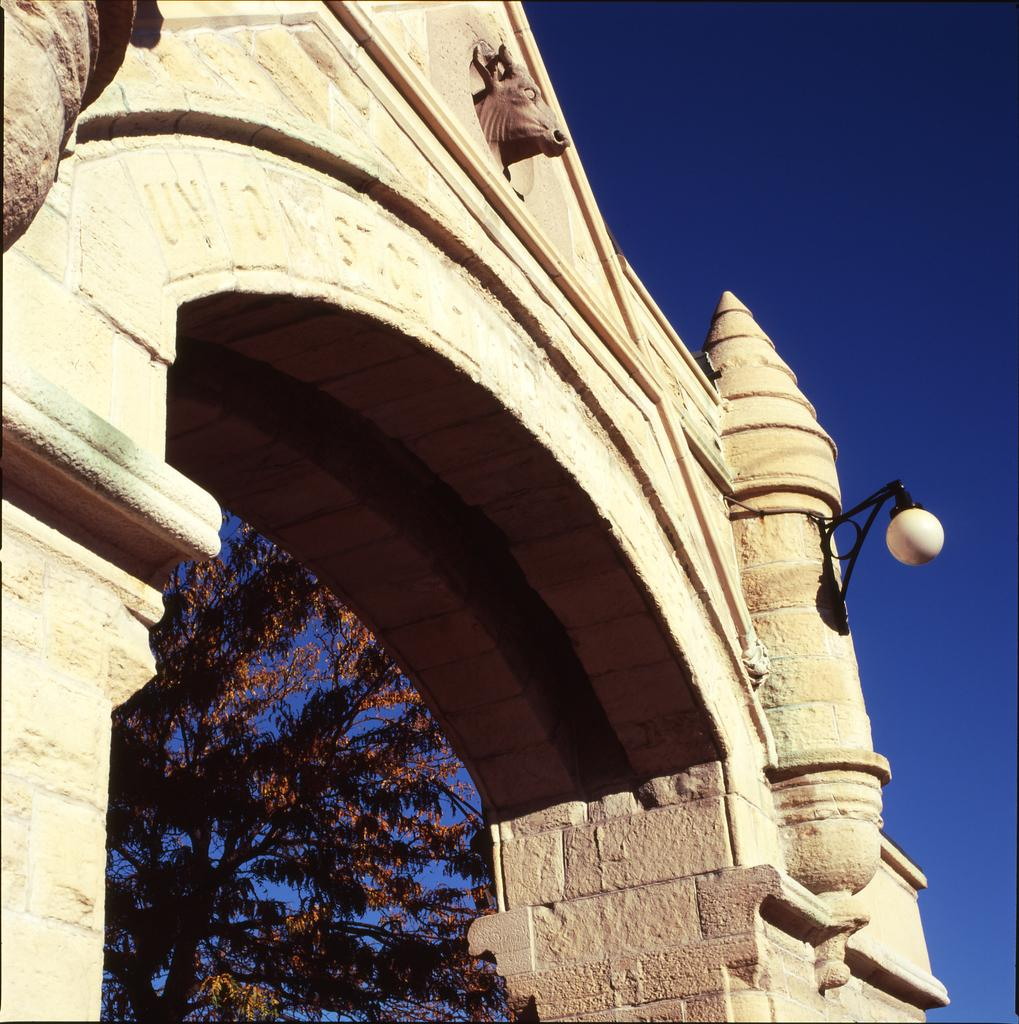What type of structure can be seen in the image? There is an arch in the image. What can be seen illuminating the area in the image? There is a light in the image. What type of writing or symbols are present in the image? There is some text in the image. What type of decoration is present on the wall in the image? There is a carving of an animal on the wall. What type of natural element is visible in the background of the image? There is a tree visible in the background of the image. What is visible in the sky in the background of the image? The sky is visible in the background of the image. How many screws can be seen holding the arch together in the image? There are no screws visible in the image; the arch is likely made of stone or another solid material. Is there a beggar asking for money in the image? There is no beggar present in the image. What type of glove is being worn by the animal carving in the image? There is no glove present in the image; it is a carving of an animal on the wall. 